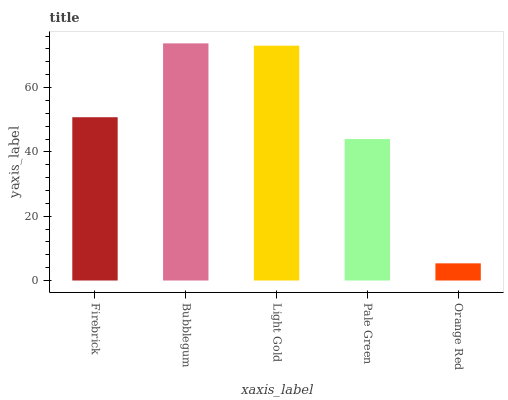Is Light Gold the minimum?
Answer yes or no. No. Is Light Gold the maximum?
Answer yes or no. No. Is Bubblegum greater than Light Gold?
Answer yes or no. Yes. Is Light Gold less than Bubblegum?
Answer yes or no. Yes. Is Light Gold greater than Bubblegum?
Answer yes or no. No. Is Bubblegum less than Light Gold?
Answer yes or no. No. Is Firebrick the high median?
Answer yes or no. Yes. Is Firebrick the low median?
Answer yes or no. Yes. Is Pale Green the high median?
Answer yes or no. No. Is Bubblegum the low median?
Answer yes or no. No. 